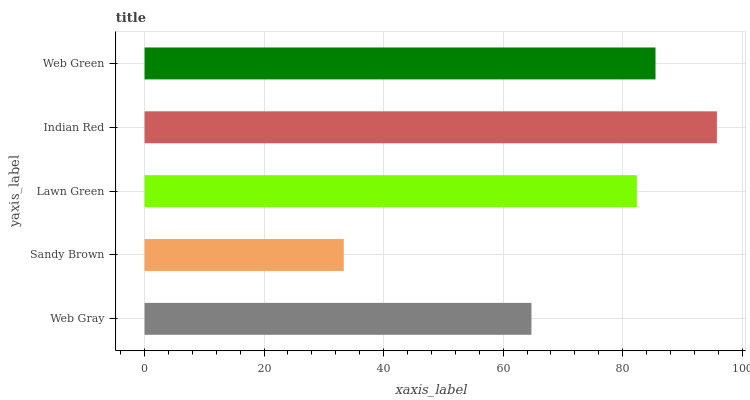Is Sandy Brown the minimum?
Answer yes or no. Yes. Is Indian Red the maximum?
Answer yes or no. Yes. Is Lawn Green the minimum?
Answer yes or no. No. Is Lawn Green the maximum?
Answer yes or no. No. Is Lawn Green greater than Sandy Brown?
Answer yes or no. Yes. Is Sandy Brown less than Lawn Green?
Answer yes or no. Yes. Is Sandy Brown greater than Lawn Green?
Answer yes or no. No. Is Lawn Green less than Sandy Brown?
Answer yes or no. No. Is Lawn Green the high median?
Answer yes or no. Yes. Is Lawn Green the low median?
Answer yes or no. Yes. Is Web Green the high median?
Answer yes or no. No. Is Web Gray the low median?
Answer yes or no. No. 